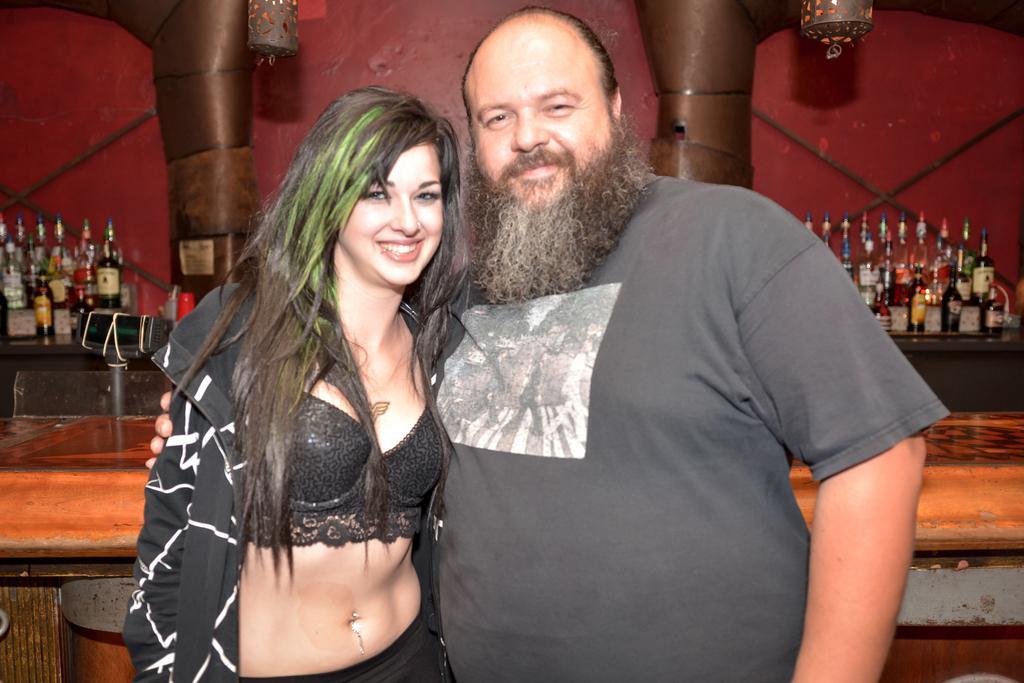Describe this image in one or two sentences. In this picture we can see a man and a woman standing and smiling and in the background we can see bottles, wall. 